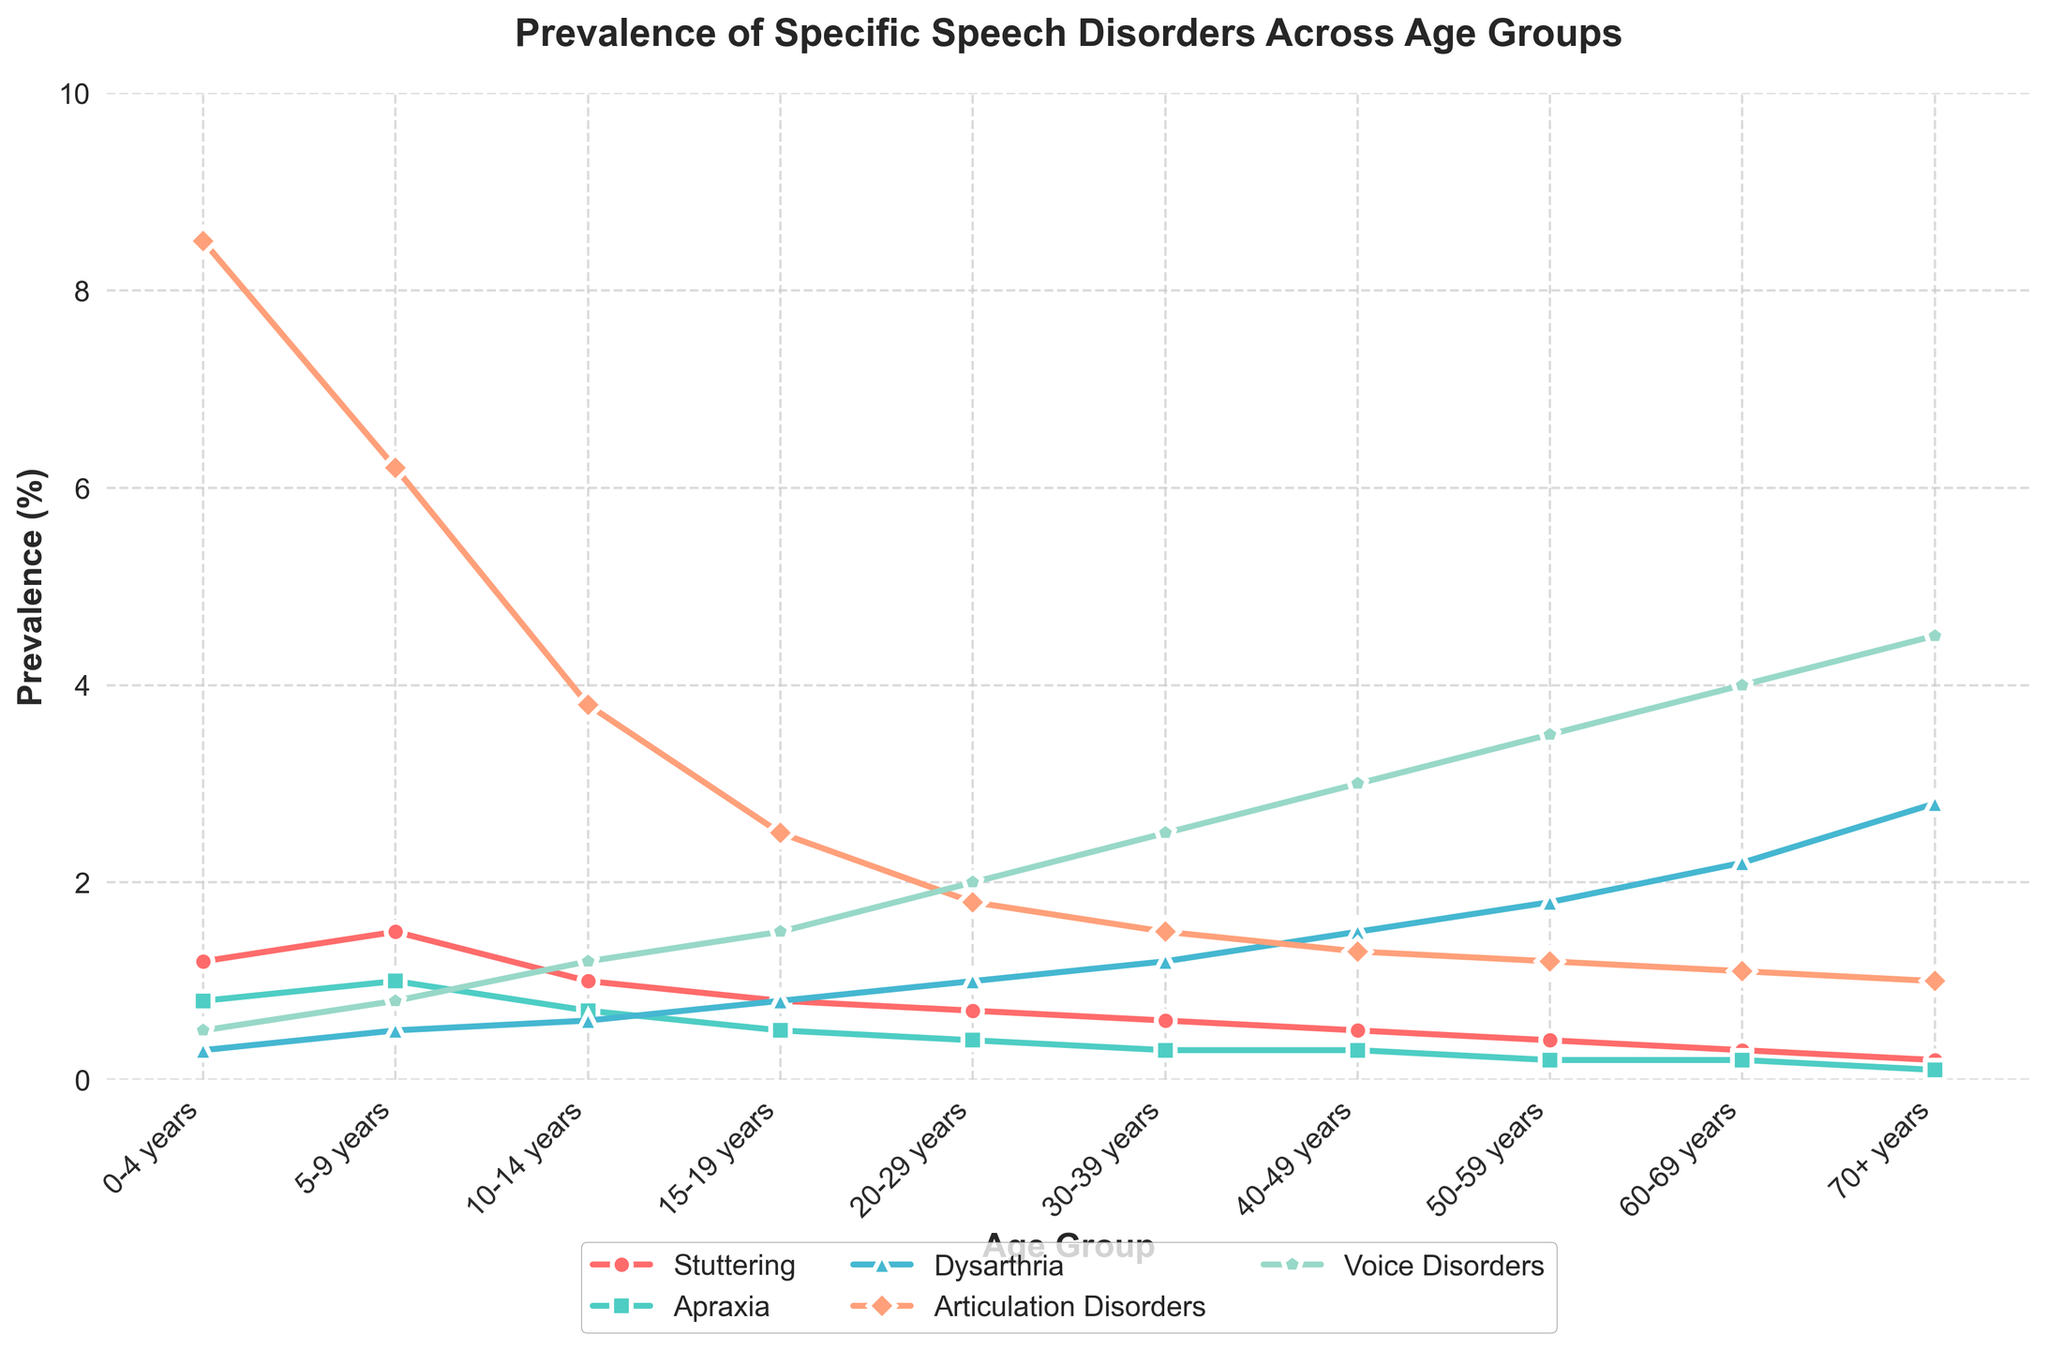What age group has the highest prevalence of articulation disorders? The highest value for articulation disorders in the line chart is at age group 0-4 years.
Answer: 0-4 years Compare the prevalence of dysarthria and voice disorders in the 70+ years age group. Which is higher? By observing the chart, dysarthria has a value of 2.8% and voice disorders have a value of 4.5% in the 70+ years age group.
Answer: Voice Disorders What is the trend for stuttering across the age groups? Stuttering shows a decreasing trend; it starts at 1.2% in the 0-4 years group and gradually decreases to 0.2% in the 70+ years group.
Answer: Decreasing Calculate the average prevalence of apraxia in age groups 0-4 years, 5-9 years, and 10-14 years. Sum of apraxia for the given age groups is (0.8 + 1.0 + 0.7) = 2.5. Average is 2.5 / 3 = 0.83.
Answer: 0.83 Which disorder has the most significant increase in prevalence from the youngest to the oldest age group? By comparing the prevalence values, voice disorders increase from 0.5% in the 0-4 years group to 4.5% in the 70+ years group, a difference of 4.0%, the highest among all disorders.
Answer: Voice Disorders In the 40-49 years age group, does apraxia or voice disorders have higher prevalence? The chart shows apraxia at 0.3% and voice disorders at 3.0% for the 40-49 years age group.
Answer: Voice Disorders What is the total prevalence of all speech disorders in the 20-29 years age group? Summing the prevalence values for this age group: 0.7 + 0.4 + 1.0 + 1.8 + 2.0 = 5.9%.
Answer: 5.9% How does the prevalence of articulation disorders change as age increases? The prevalence of articulation disorders shows a decreasing trend, starting at 8.5% in the 0-4 years group and reducing to 1.0% in the 70+ years group.
Answer: Decreasing Compare the prevalence of stuttering between the 0-4 years and 10-14 years age groups. The prevalence of stuttering is 1.2% in the 0-4 years group and 1.0% in the 10-14 years group.
Answer: 0.2% higher in 0-4 years 